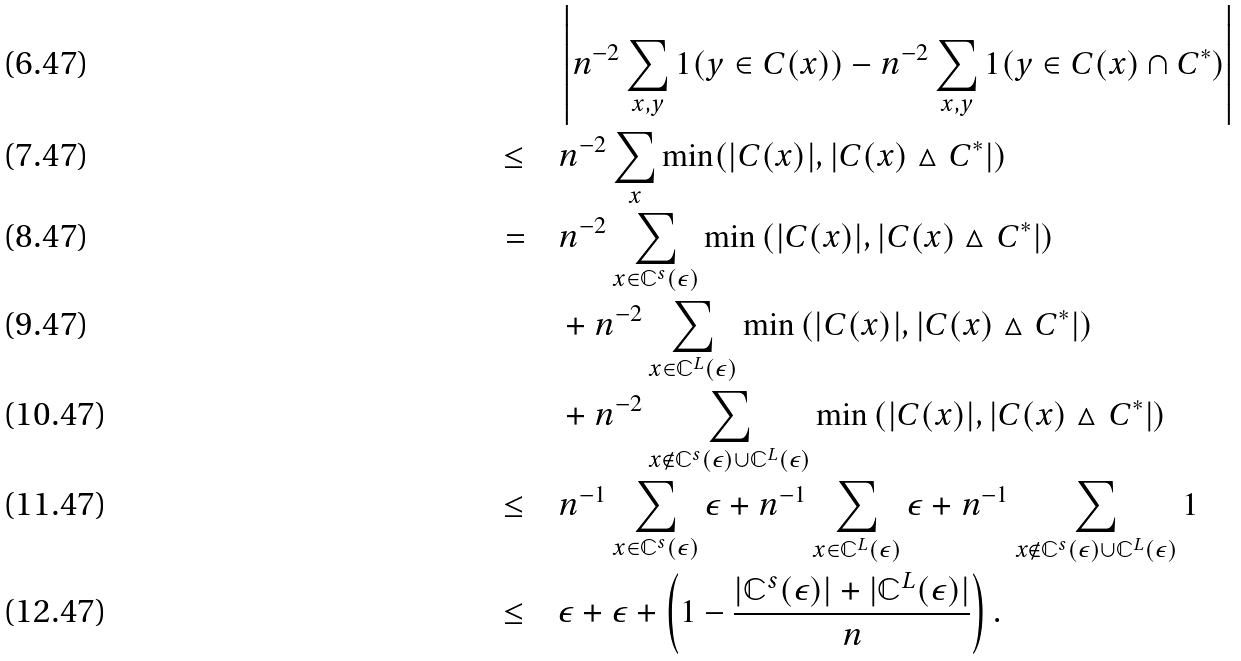Convert formula to latex. <formula><loc_0><loc_0><loc_500><loc_500>& \left | n ^ { - 2 } \sum _ { x , y } 1 ( y \in C ( x ) ) - n ^ { - 2 } \sum _ { x , y } 1 ( y \in C ( x ) \cap C ^ { * } ) \right | \\ \leq \quad & n ^ { - 2 } \sum _ { x } \min ( | C ( x ) | , | C ( x ) \vartriangle C ^ { * } | ) \\ = \quad & n ^ { - 2 } \sum _ { x \in \mathbb { C } ^ { s } ( \epsilon ) } \min \left ( | C ( x ) | , | C ( x ) \vartriangle C ^ { * } | \right ) \\ & + n ^ { - 2 } \sum _ { x \in \mathbb { C } ^ { L } ( \epsilon ) } \min \left ( | C ( x ) | , | C ( x ) \vartriangle C ^ { * } | \right ) \\ & + n ^ { - 2 } \sum _ { x \notin \mathbb { C } ^ { s } ( \epsilon ) \cup \mathbb { C } ^ { L } ( \epsilon ) } \min \left ( | C ( x ) | , | C ( x ) \vartriangle C ^ { * } | \right ) \\ \leq \quad & n ^ { - 1 } \sum _ { x \in \mathbb { C } ^ { s } ( \epsilon ) } \epsilon + n ^ { - 1 } \sum _ { x \in \mathbb { C } ^ { L } ( \epsilon ) } \epsilon + n ^ { - 1 } \sum _ { x \notin \mathbb { C } ^ { s } ( \epsilon ) \cup \mathbb { C } ^ { L } ( \epsilon ) } 1 \\ \leq \quad & \epsilon + \epsilon + \left ( 1 - \frac { | \mathbb { C } ^ { s } ( \epsilon ) | + | \mathbb { C } ^ { L } ( \epsilon ) | } { n } \right ) .</formula> 